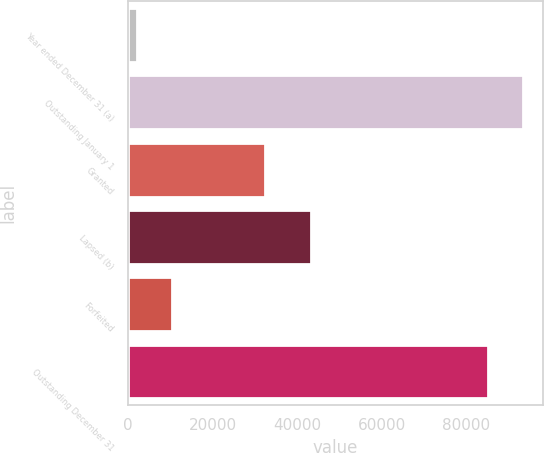<chart> <loc_0><loc_0><loc_500><loc_500><bar_chart><fcel>Year ended December 31 (a)<fcel>Outstanding January 1<fcel>Granted<fcel>Lapsed (b)<fcel>Forfeited<fcel>Outstanding December 31<nl><fcel>2004<fcel>93451.3<fcel>32514<fcel>43349<fcel>10356.3<fcel>85099<nl></chart> 